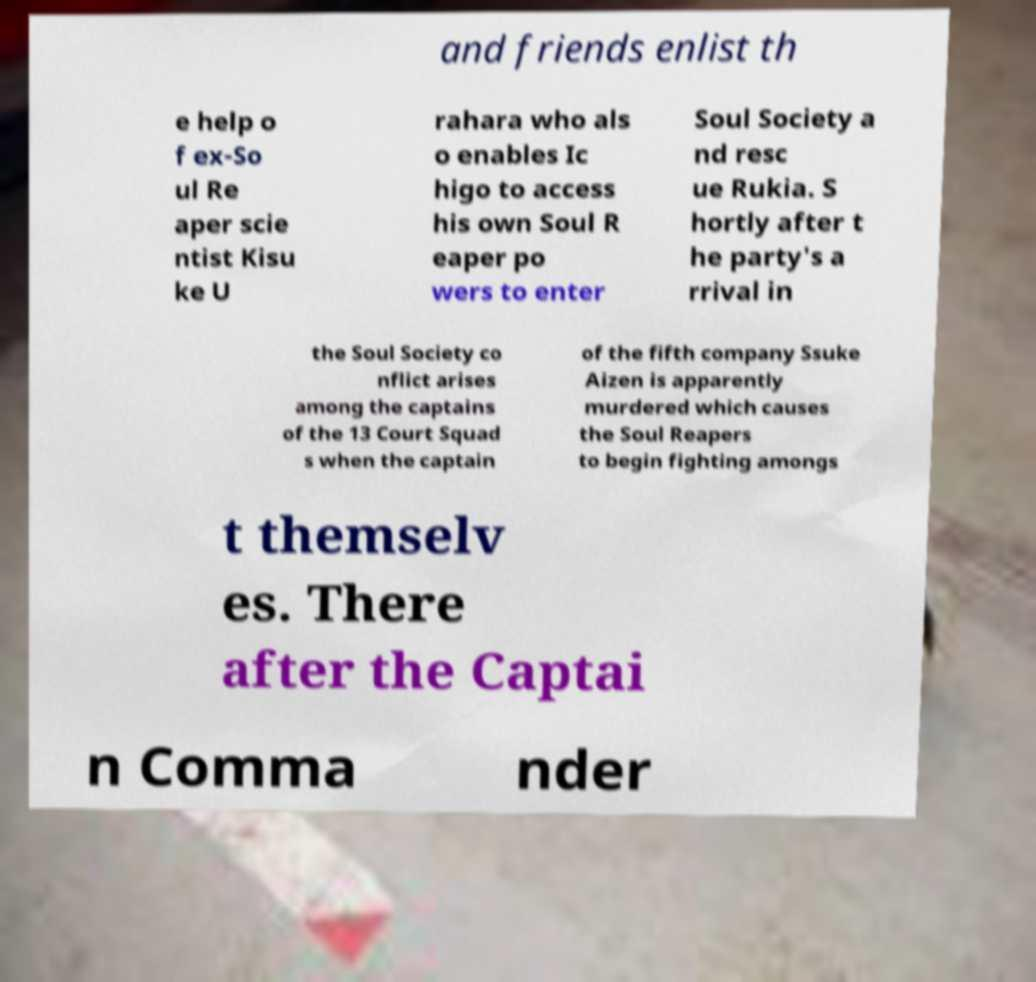Please identify and transcribe the text found in this image. and friends enlist th e help o f ex-So ul Re aper scie ntist Kisu ke U rahara who als o enables Ic higo to access his own Soul R eaper po wers to enter Soul Society a nd resc ue Rukia. S hortly after t he party's a rrival in the Soul Society co nflict arises among the captains of the 13 Court Squad s when the captain of the fifth company Ssuke Aizen is apparently murdered which causes the Soul Reapers to begin fighting amongs t themselv es. There after the Captai n Comma nder 